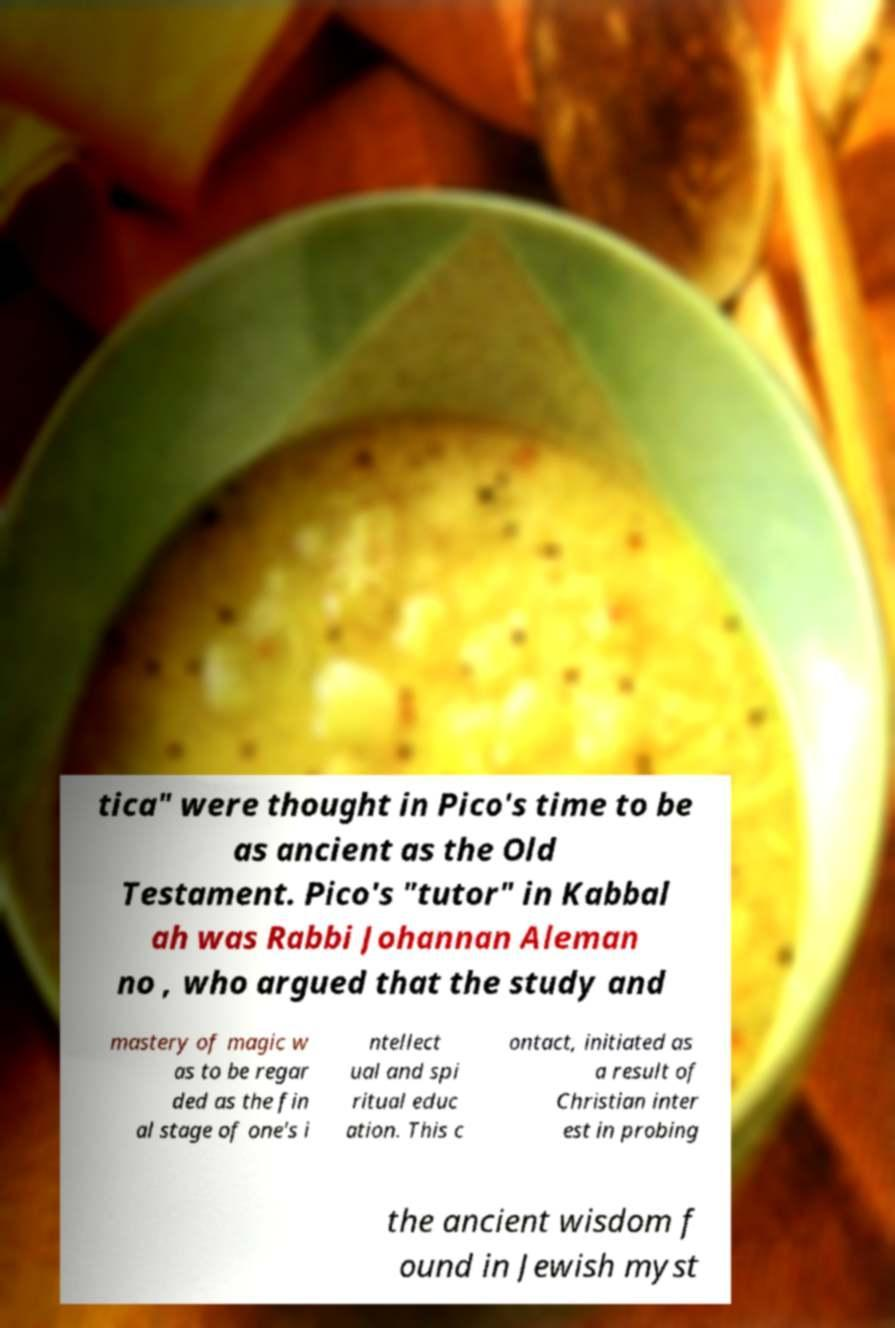Can you read and provide the text displayed in the image?This photo seems to have some interesting text. Can you extract and type it out for me? tica" were thought in Pico's time to be as ancient as the Old Testament. Pico's "tutor" in Kabbal ah was Rabbi Johannan Aleman no , who argued that the study and mastery of magic w as to be regar ded as the fin al stage of one's i ntellect ual and spi ritual educ ation. This c ontact, initiated as a result of Christian inter est in probing the ancient wisdom f ound in Jewish myst 